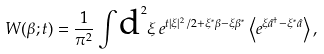<formula> <loc_0><loc_0><loc_500><loc_500>W ( \beta ; t ) = \frac { 1 } { \pi ^ { 2 } } \int \text {d} ^ { 2 } \xi \, e ^ { t | \xi | ^ { 2 } / 2 + \xi ^ { \ast } \beta - \xi \beta ^ { \ast } } \left \langle e ^ { \xi \hat { a } ^ { \dagger } - \xi ^ { \ast } \hat { a } } \right \rangle ,</formula> 